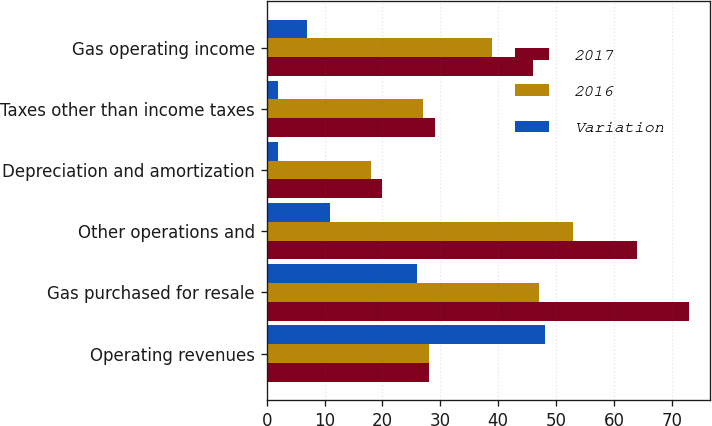Convert chart to OTSL. <chart><loc_0><loc_0><loc_500><loc_500><stacked_bar_chart><ecel><fcel>Operating revenues<fcel>Gas purchased for resale<fcel>Other operations and<fcel>Depreciation and amortization<fcel>Taxes other than income taxes<fcel>Gas operating income<nl><fcel>2017<fcel>28<fcel>73<fcel>64<fcel>20<fcel>29<fcel>46<nl><fcel>2016<fcel>28<fcel>47<fcel>53<fcel>18<fcel>27<fcel>39<nl><fcel>Variation<fcel>48<fcel>26<fcel>11<fcel>2<fcel>2<fcel>7<nl></chart> 